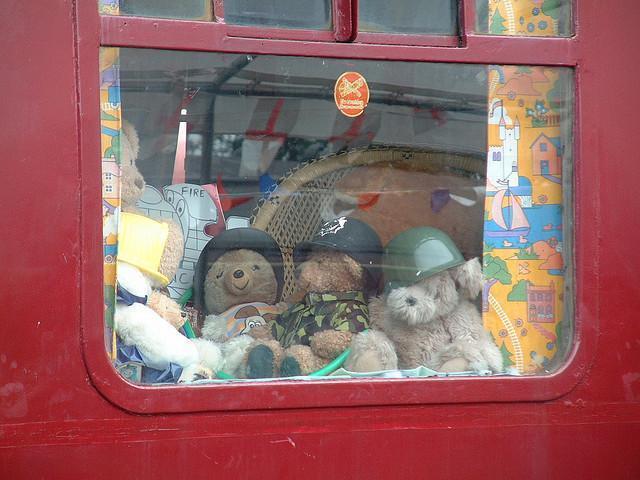How many teddy bears can be seen?
Give a very brief answer. 4. How many cows are outside?
Give a very brief answer. 0. 